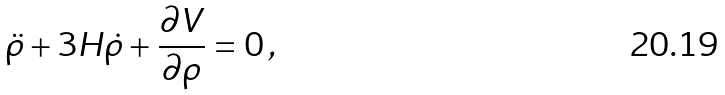<formula> <loc_0><loc_0><loc_500><loc_500>\ddot { \rho } + 3 H \dot { \rho } + \frac { \partial V } { \partial \rho } = 0 \, ,</formula> 